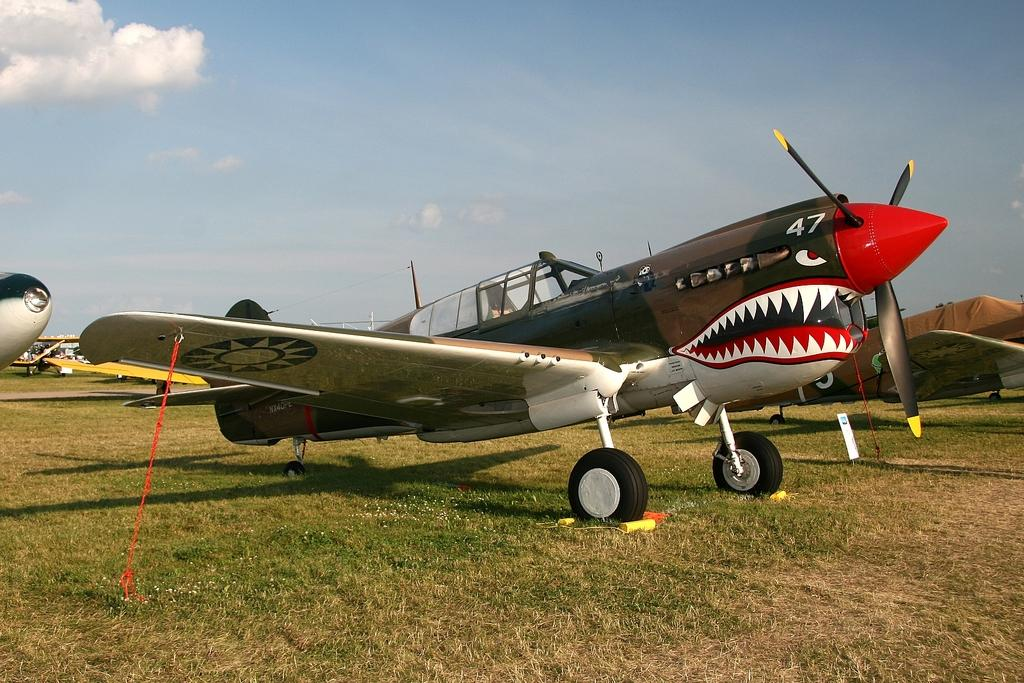What is the main subject of the image? The main subject of the image is airplanes on the ground. Can you describe the location of the airplanes in the image? The airplanes are on the ground in the image. What can be seen in the background of the image? The sky is visible in the background of the image. How many ants can be seen crawling on the airplanes in the image? There are no ants visible in the image; it features airplanes on the ground with the sky in the background. 